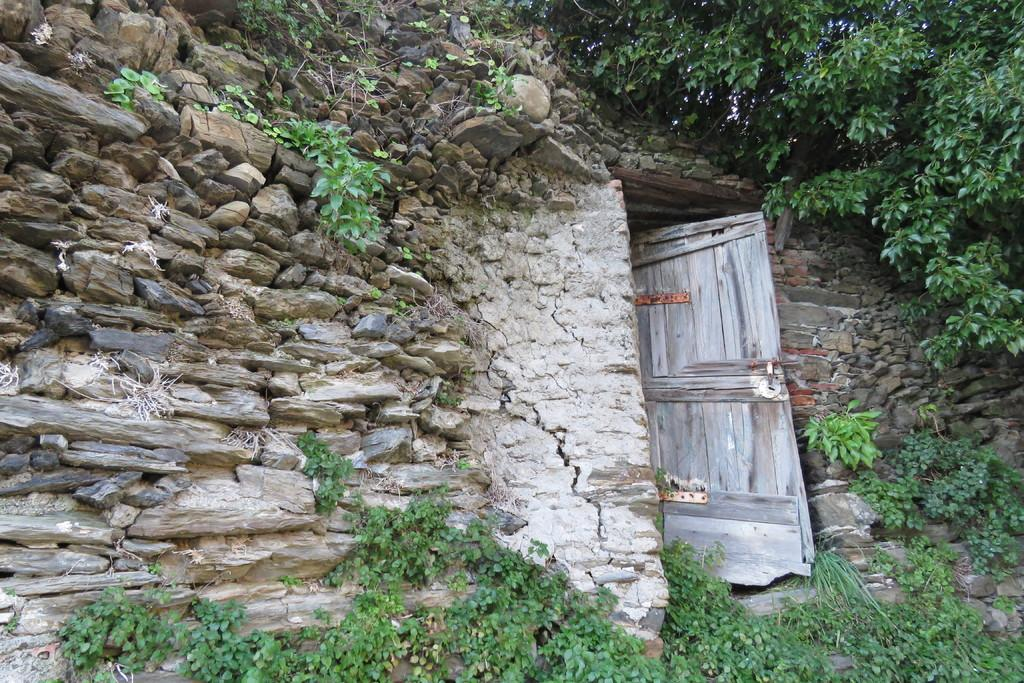What type of structure can be seen in the picture? There is a stonewall in the picture. What is the entrance to the structure? There is a wooden door in the picture. What type of vegetation is present in the picture? There are plants in the picture. Where is the tree located in the picture? There is a tree on the right side of the picture. What type of pipe can be seen in the picture? There is no pipe present in the picture. What behavior can be observed in the tree on the right side of the picture? There is no behavior to observe in the tree, as it is a static object in the image. 